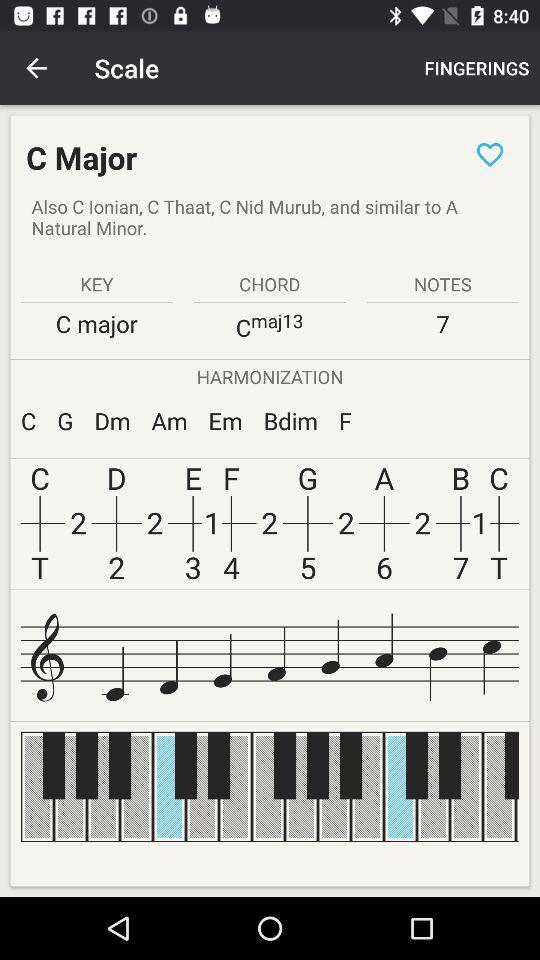How many notes are there? There are 7 notes. 